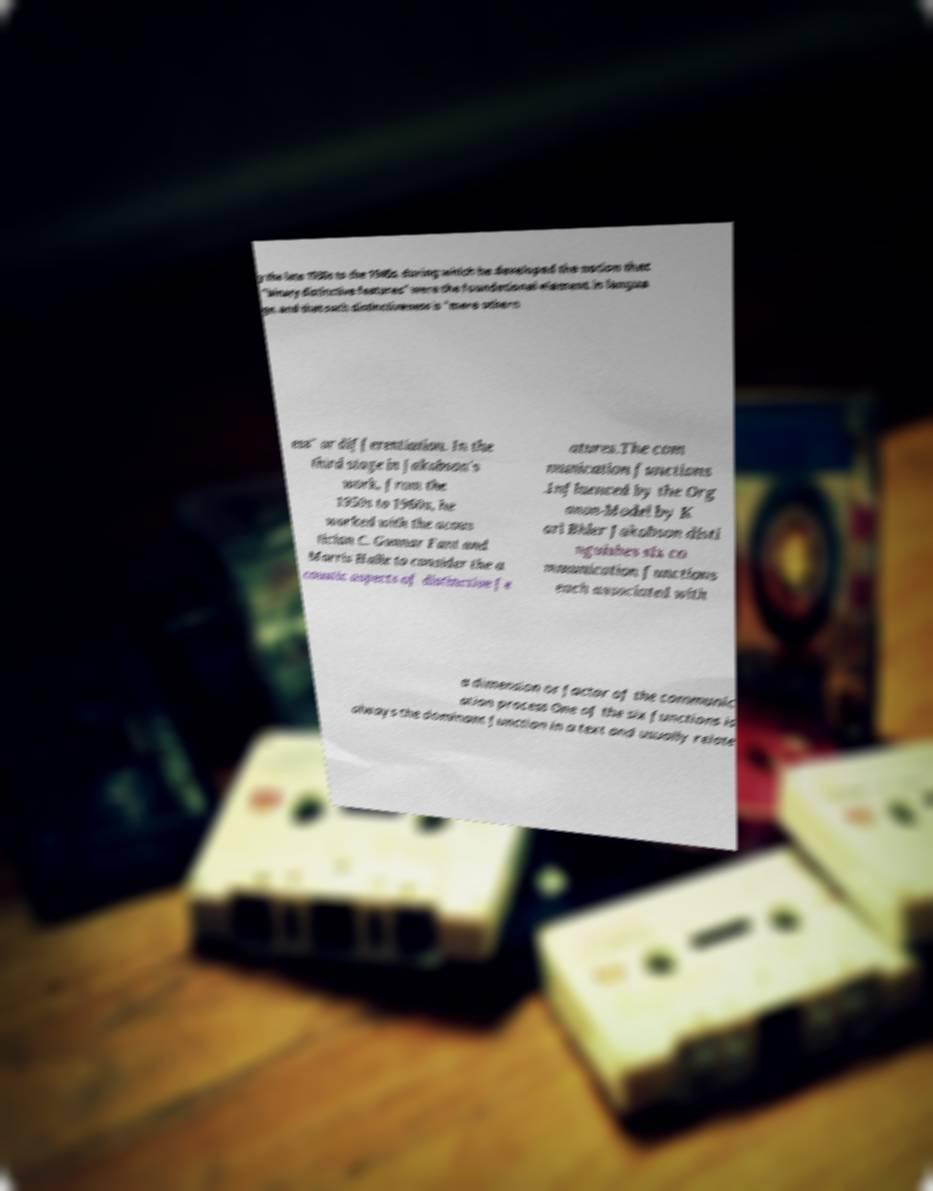Could you extract and type out the text from this image? y the late 1930s to the 1940s, during which he developed the notion that "binary distinctive features" were the foundational element in langua ge, and that such distinctiveness is "mere othern ess" or differentiation. In the third stage in Jakobson's work, from the 1950s to 1960s, he worked with the acous tician C. Gunnar Fant and Morris Halle to consider the a coustic aspects of distinctive fe atures.The com munication functions .Influenced by the Org anon-Model by K arl Bhler Jakobson disti nguishes six co mmunication functions each associated with a dimension or factor of the communic ation process One of the six functions is always the dominant function in a text and usually relate 